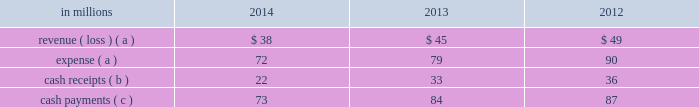Also during 2006 , the entities acquired approximately $ 4.8 billion of international paper debt obligations for cash , resulting in a total of approximately $ 5.2 billion of international paper debt obligations held by the entities at december 31 , 2006 .
The various agreements entered into in connection with these transactions provide that international paper has , and intends to effect , a legal right to offset its obligation under these debt instruments with its investments in the entities .
Accordingly , for financial reporting purposes , international paper has offset approximately $ 5.2 billion of class b interests in the entities against $ 5.3 billion of international paper debt obligations held by these entities at december 31 , 2014 and 2013 .
Despite the offset treatment , these remain debt obligations of international paper .
Remaining borrowings of $ 50 million and $ 67 million at december 31 , 2014 and 2013 , respectively , are included in floating rate notes due 2014 2013 2019 in the summary of long-term debt in note 13 .
Additional debt related to the above transaction of $ 107 million and $ 79 million is included in short-term notes in the summary of long-term debt in note 13 at december 31 , 2014 and 2013 .
The use of the above entities facilitated the monetization of the credit enhanced timber notes in a cost effective manner by increasing the borrowing capacity and lowering the interest rate , while providing for the offset accounting treatment described above .
Additionally , the monetization structure preserved the tax deferral that resulted from the 2006 forestlands sales .
The company recognized a $ 1.4 billion deferred tax liability in connection with the 2006 forestlands sale , which will be settled with the maturity of the timber notes in the third quarter of 2016 ( unless extended ) .
During 2011 and 2012 , the credit ratings for two letter of credit banks that support $ 1.5 billion of timber notes were downgraded below the specified threshold .
These letters of credit were successfully replaced by other qualifying institutions .
Fees of $ 10 million were incurred during 2012 in connection with these replacements .
During 2012 , an additional letter of credit bank that supports $ 707 million of timber notes was downgraded below the specified threshold .
In december 2012 , the company and the third-party managing member agreed to a continuing replacement waiver for these letters of credit , terminable upon 30 days notice .
Activity between the company and the entities was as follows: .
( a ) the net expense related to the company 2019s interest in the entities is included in interest expense , net in the accompanying consolidated statement of operations , as international paper has and intends to effect its legal right to offset as discussed above .
( b ) the cash receipts are equity distributions from the entities to international paper .
( c ) the semi-annual payments are related to interest on the associated debt obligations discussed above .
Based on an analysis of the entities discussed above under guidance that considers the potential magnitude of the variability in the structures and which party has a controlling financial interest , international paper determined that it is not the primary beneficiary of the entities , and therefore , should not consolidate its investments in these entities .
It was also determined that the source of variability in the structure is the value of the timber notes , the assets most significantly impacting the structure 2019s economic performance .
The credit quality of the timber notes is supported by irrevocable letters of credit obtained by third-party buyers which are 100% ( 100 % ) cash collateralized .
International paper analyzed which party has control over the economic performance of each entity , and concluded international paper does not have control over significant decisions surrounding the timber notes and letters of credit and therefore is not the primary beneficiary .
The company 2019s maximum exposure to loss equals the value of the timber notes ; however , an analysis performed by the company concluded the likelihood of this exposure is remote .
International paper also held variable interests in financing entities that were used to monetize long-term notes received from the sale of forestlands in 2002 .
International paper transferred notes ( the monetized notes , with an original maturity of 10 years from inception ) and cash of approximately $ 500 million to these entities in exchange for preferred interests , and accounted for the transfers as a sale of the notes with no associated gain or loss .
In the same period , the entities acquired approximately $ 500 million of international paper debt obligations for cash .
International paper has no obligation to make any further capital contributions to these entities and did not provide any financial support that was not previously contractually required during the years ended december 31 , 2014 , 2013 or 2012 .
During 2012 , $ 252 million of the 2002 monetized notes matured .
Cash receipts upon maturity were used to pay the associated debt obligations .
Effective june 1 , 2012 , international paper liquidated its interest in the 2002 financing entities .
In connection with the acquisition of temple-inland in february 2012 , two special purpose entities became wholly-owned subsidiaries of international paper. .
In the review of the activity between the company and the entities what was the ratio of the cash payments to the cash receipts? 
Computations: (73 / 22)
Answer: 3.31818. 